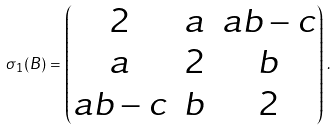Convert formula to latex. <formula><loc_0><loc_0><loc_500><loc_500>\sigma _ { 1 } ( B ) = \begin{pmatrix} 2 & a & a b - c \\ a & 2 & b \\ a b - c & b & 2 \end{pmatrix} \, .</formula> 